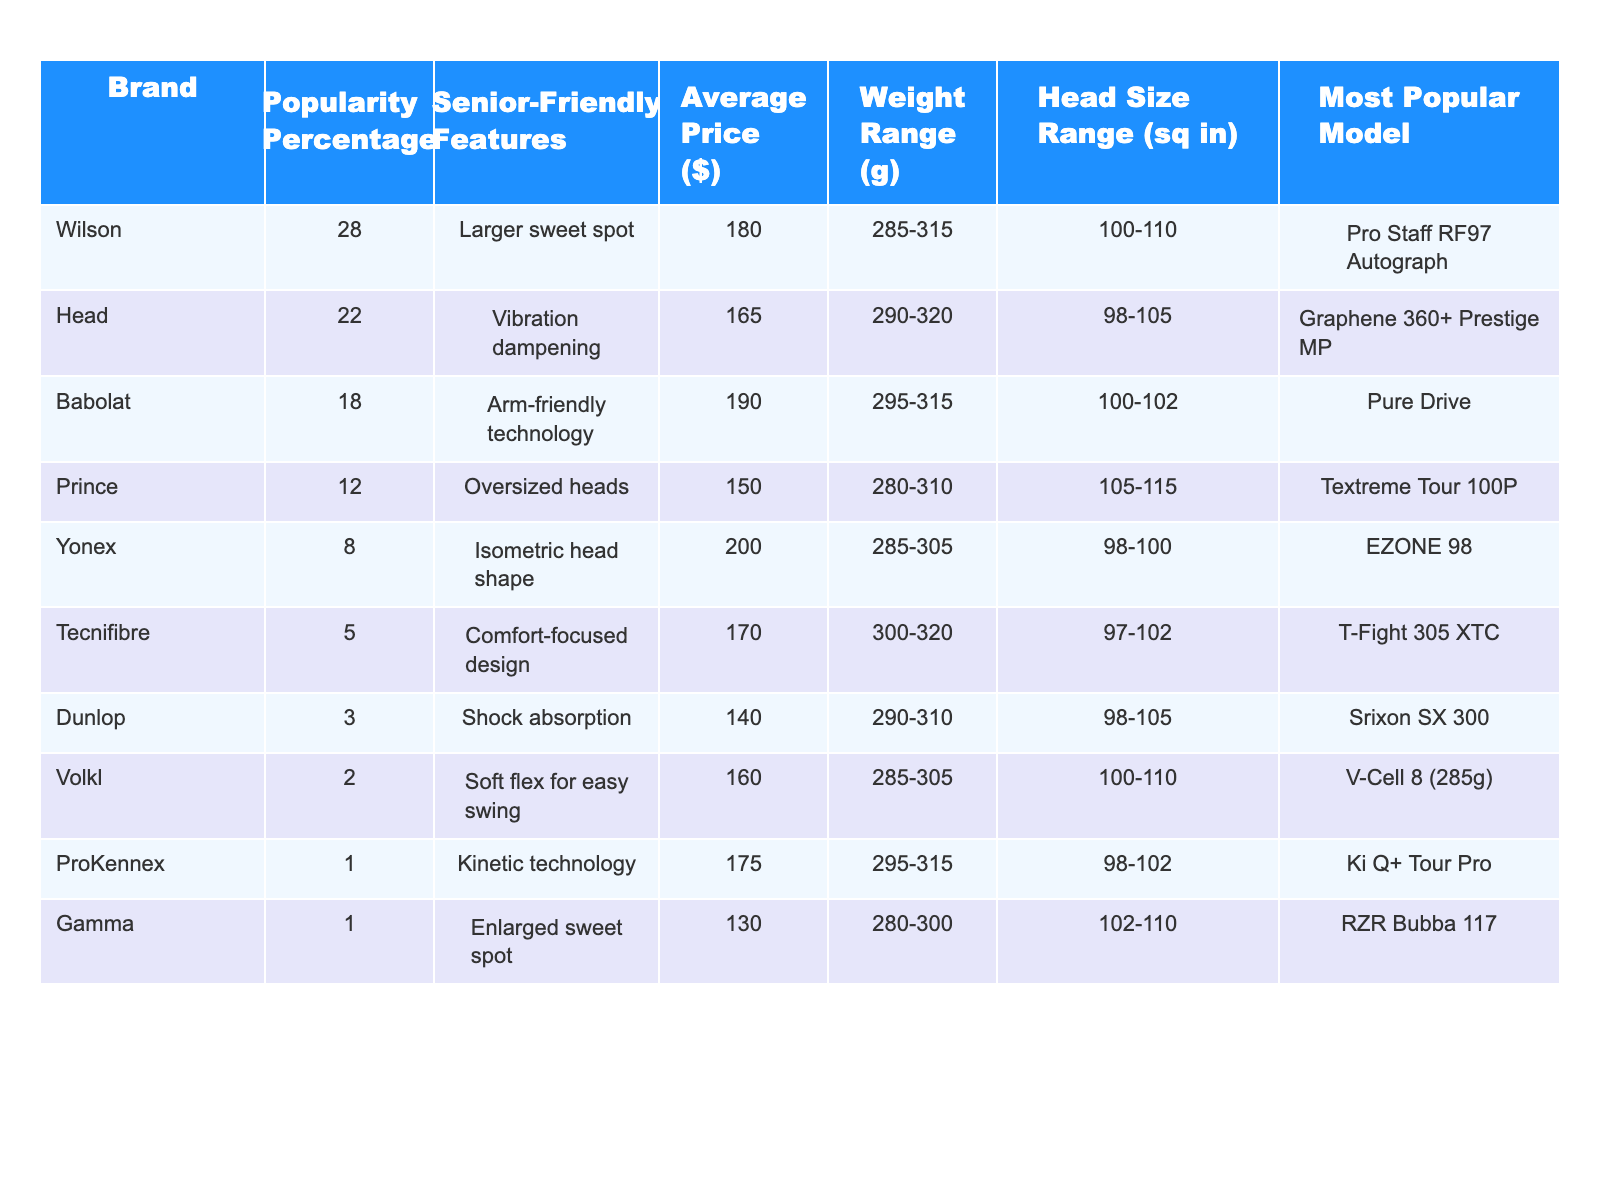What's the most popular tennis racket brand among senior players? Looking at the Popularity Percentage column, Wilson has the highest value at 28%.
Answer: Wilson How many brands have a popularity percentage greater than 10%? Checking the Popularity Percentage column, the brands Wilson, Head, Babolat, and Prince all have values greater than 10%, totaling four brands.
Answer: 4 Which brand has the highest average price? The Average Price column shows that Babolat has the highest value at $190.
Answer: Babolat What is the average weight range of the top three brands? The weight ranges for the top three brands (Wilson, Head, Babolat) are 285-315g, 290-320g, and 295-315g respectively. The average of their ranges is calculated as: (300 + 305 + 305) / 3 = 303.33g.
Answer: 303.33g Is there a brand that has a popularity percentage of 1%? Looking at the Popularity Percentage column, both ProKennex and Gamma have a popularity percentage of 1%.
Answer: Yes Which brand is known for its shock absorption technology? From the Senior-Friendly Features column, Dunlop is noted for its shock absorption feature.
Answer: Dunlop What is the average popularity percentage of brands that have senior-friendly features specifically related to comfort? The brands with comfort-focused features are Tecnifibre (5%) and Babolat (18%). The average is calculated as (5 + 18) / 2 = 11.5%.
Answer: 11.5% Which racket brand offers the largest head size range? Examining the Head Size Range column, Prince has the largest range of 105-115 sq inches.
Answer: Prince How much cheaper is the average price of Yonex compared to the average price of Wilson? Wilson's average price is $180 and Yonex's is $200. The difference is $200 - $180 = $20.
Answer: $20 Which brand features arm-friendly technology and what is its popularity percentage? Babolat features arm-friendly technology and has a popularity percentage of 18%.
Answer: Babolat, 18% 